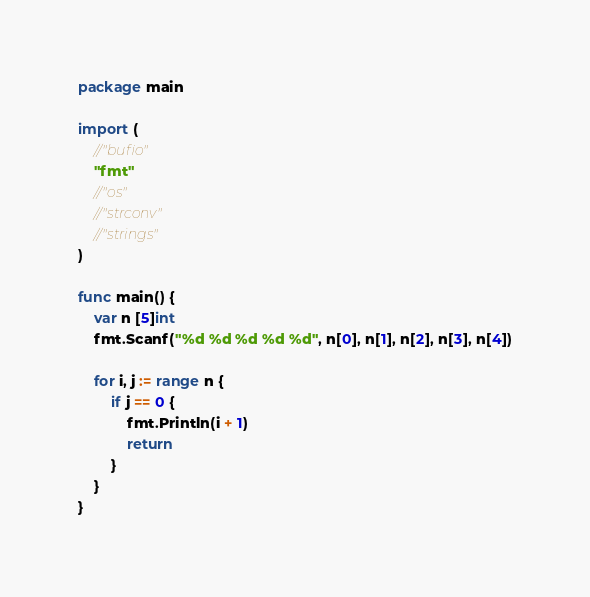<code> <loc_0><loc_0><loc_500><loc_500><_Go_>package main

import (
	//"bufio"
	"fmt"
	//"os"
	//"strconv"
	//"strings"
)

func main() {
	var n [5]int
	fmt.Scanf("%d %d %d %d %d", n[0], n[1], n[2], n[3], n[4])

	for i, j := range n {
		if j == 0 {
			fmt.Println(i + 1)
			return
		}
	}
}</code> 